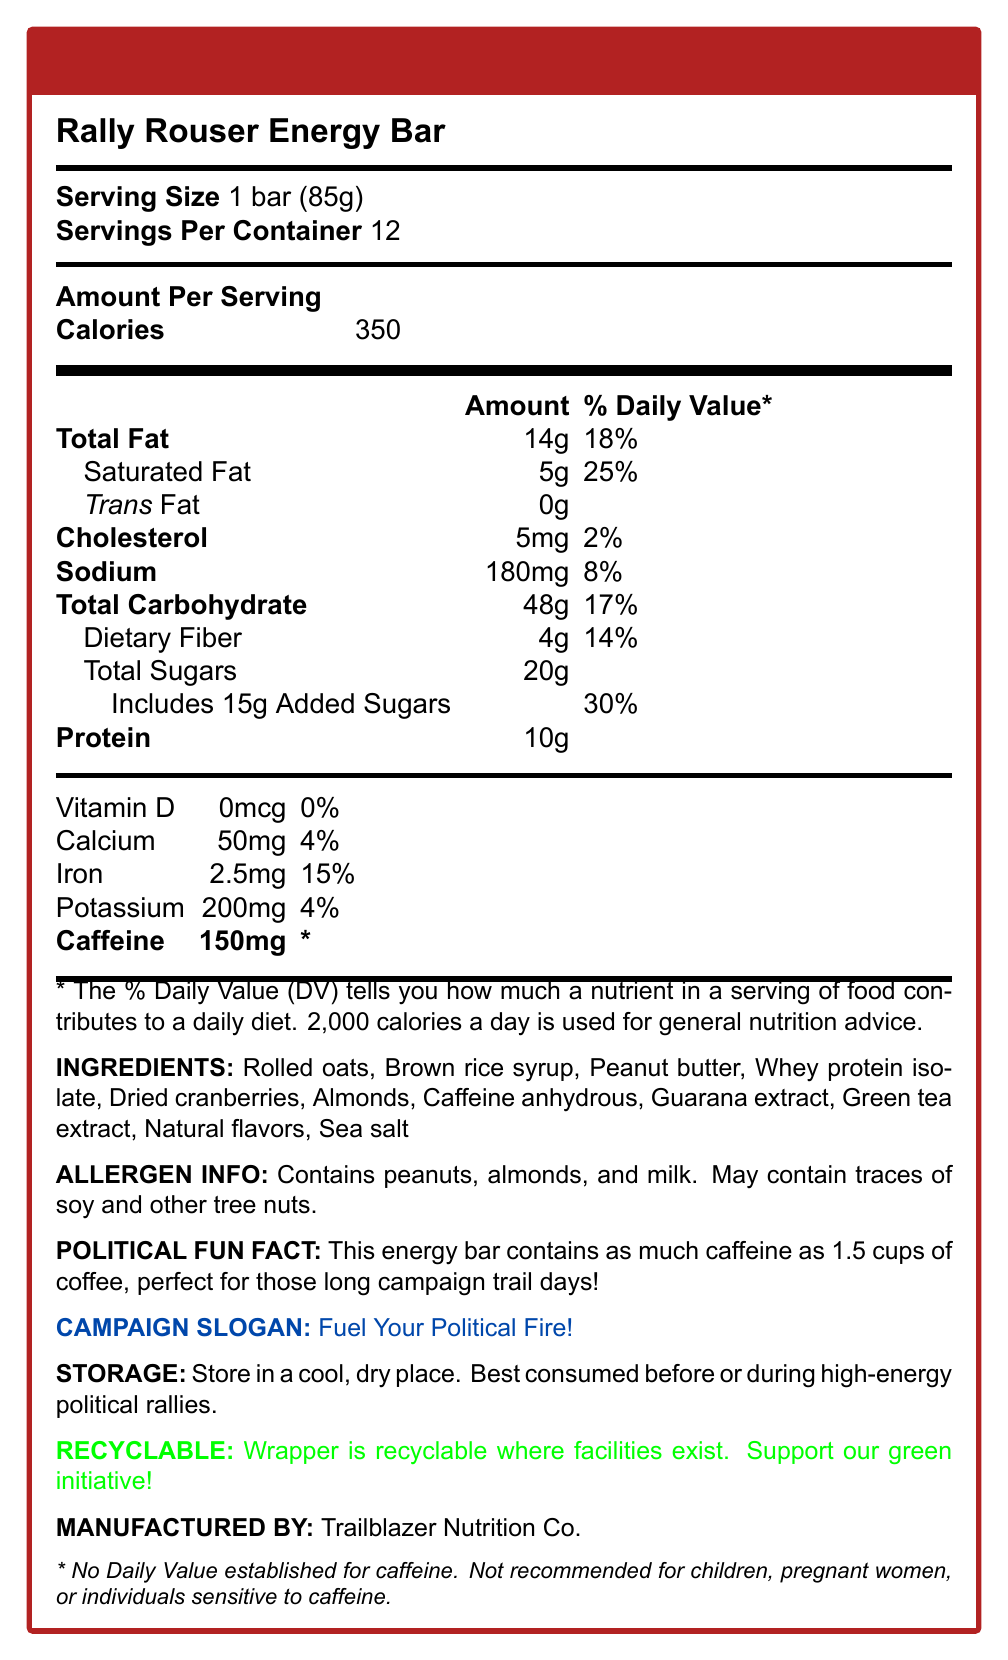what is the serving size? The document specifies that the serving size is 1 bar (85g).
Answer: 1 bar (85g) how many servings are there per container? The document lists "Servings Per Container" as 12.
Answer: 12 how many calories are in a single bar? Under the "Amount Per Serving" section, it states that each bar contains 350 calories.
Answer: 350 what percentage of the Daily Value of saturated fat does one bar provide? The document lists saturated fat content as 5g, which is 25% of the Daily Value.
Answer: 25% how much protein is in one bar? The document states that one bar contains 10g of protein.
Answer: 10g which ingredients are allergens? The allergen information section specifies that the bar contains peanuts, almonds, and milk.
Answer: Peanuts, almonds, and milk how much caffeine is in one energy bar? Under the nutrition information, it states that one bar contains 150mg of caffeine.
Answer: 150mg what is the campaign slogan for Rally Rouser Energy Bar? The campaign slogan is listed as "Fuel Your Political Fire!".
Answer: Fuel Your Political Fire! how should the Rally Rouser Energy Bar be stored? The storage instructions specify that the bar should be stored in a cool, dry place.
Answer: In a cool, dry place review the entire document: identify the allergens listed for Rally Rouser Energy Bar and their potential presence in trace amounts The allergen info section mentions that the bar contains peanuts, almonds, and milk, and may contain traces of soy and other tree nuts.
Answer: Peanuts, almonds, milk; may contain traces of soy and other tree nuts what is the recommended audience for the Rally Rouser Energy Bar due to its caffeine content? The disclaimer states that the bar is not recommended for children, pregnant women, or individuals sensitive to caffeine.
Answer: Not recommended for children, pregnant women, or individuals sensitive to caffeine which item in the ingredients list might be responsible for the caffeine content? (select all that apply) A. Rolled oats B. Caffeine anhydrous C. Guarana extract D. Green tea extract Options B, C, and D (Caffeine anhydrous, Guarana extract, Green tea extract) are all sources of caffeine listed in the ingredients.
Answer: B, C, D which of the following nutrients is listed as having 0% Daily Value in one bar? A. Vitamin D B. Calcium C. Iron D. Potassium Vitamin D is listed as having 0% Daily Value in the nutrition information.
Answer: A is there any trans fat in the Rally Rouser Energy Bar? The document states "Trans Fat 0g" indicating there is no trans fat.
Answer: No provide a brief summary of the Rally Rouser Energy Bar's nutrition facts The detailed sections list these specific nutritional elements, making it a good summary of the product.
Answer: This bar contains 350 calories per serving, with significant amounts of protein and caffeine. It has 14g of fat, 48g of carbohydrates, and 10g of protein. It is high in added sugars and certain minerals. The bar is designed to energize and fuel high-energy activities such as political rallies. what is the environmental initiative mentioned in the document? The recyclable note indicates that the wrapper is recyclable and encourages the green initiative.
Answer: Wrapper is recyclable where facilities exist. Support our green initiative! What are the exact caffeine content figures given for the Rally Rouser Energy Bar and its equivalent in coffee cups? The document states the caffeine content is 150mg, which is as much as 1.5 cups of coffee, but it does not specify the exact caffeine content of the coffee measurement used.
Answer: Not enough information 